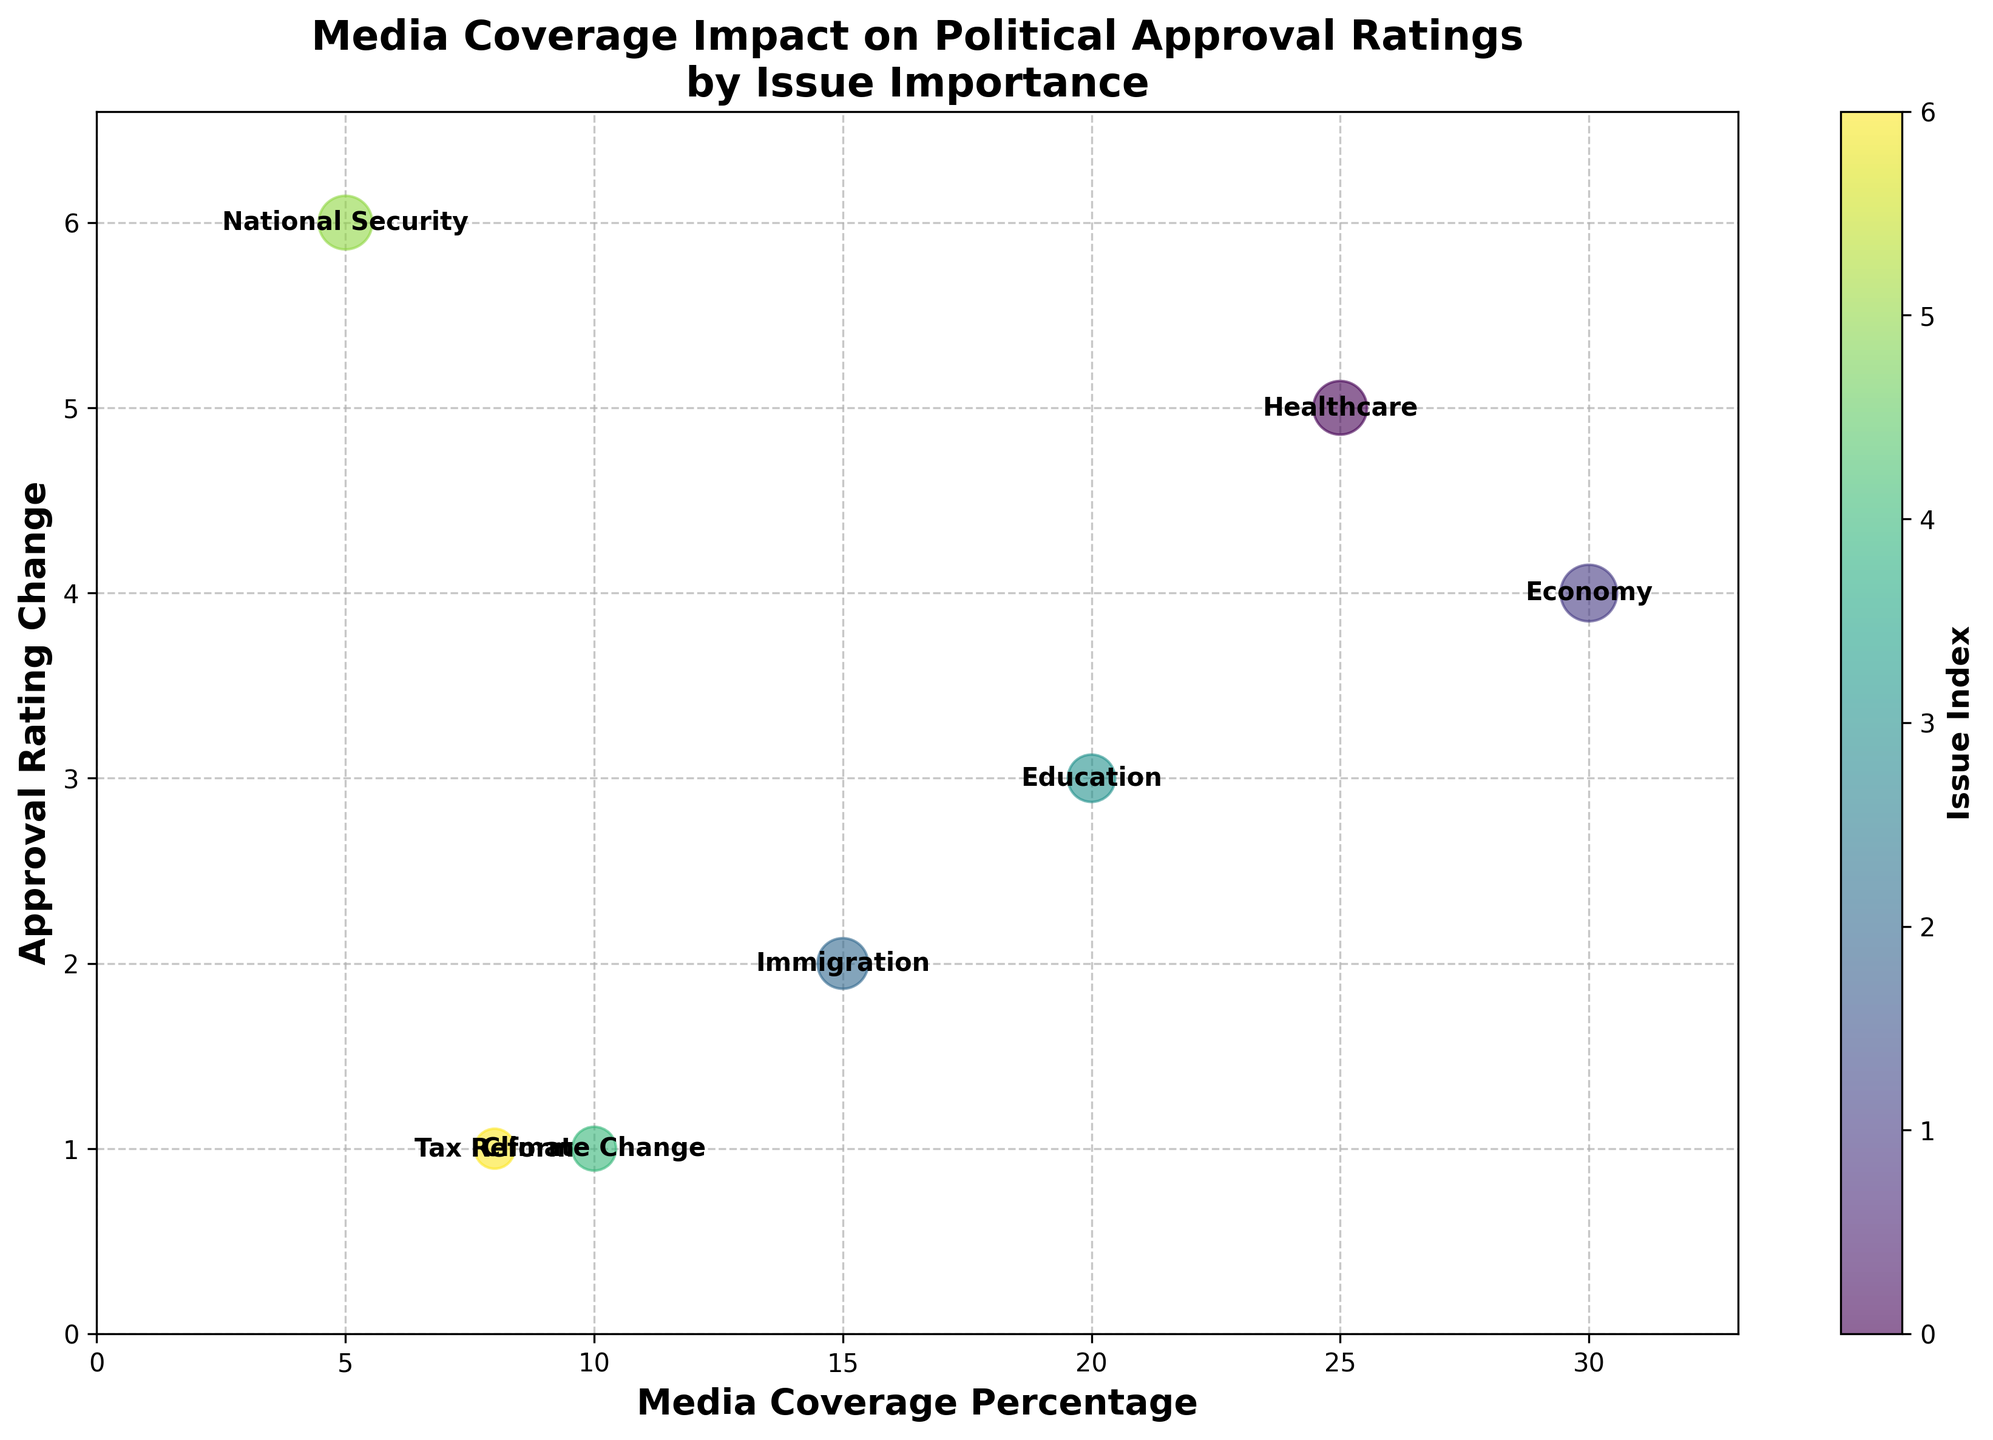What is the title of the chart? The title is usually displayed at the top of the chart. It provides a summary of what the chart is about.
Answer: Media Coverage Impact on Political Approval Ratings by Issue Importance What are the x-axis and y-axis labels? The x-axis label indicates what each point's horizontal position represents. The y-axis label indicates what each point's vertical position represents.
Answer: x-axis: Media Coverage Percentage, y-axis: Approval Rating Change How many issues are represented in the chart? Count each uniquely labeled bubble, as each corresponds to an issue. Annotated labels help identify them.
Answer: 7 Which issue has the highest approval rating change? Look for the bubble positioned highest on the y-axis since this implies the greatest approval rating change.
Answer: National Security What is the range of Media Coverage Percentage? Check the extreme left and right positions along the x-axis to determine the smallest and largest values.
Answer: 0 to 30 What's the total Media Coverage Percentage for the issues that have an Approval Rating Change greater than or equal to 3? Identify the issues with Approval Rating Change ≥ 3, then sum their Media Coverage Percentages. Economy (30) + Healthcare (25) + Education (20) = 75
Answer: 75 Which issue has the smallest Media Coverage Percentage and what is its Approval Rating Change? Find the bubble closest to the y-axis along the x-axis to identify the lowest percentage, then check its y-coordinate.
Answer: National Security, 6 Compare the Approval Rating Change between Healthcare and Economy. Which one has a higher change? Locate the Healthcare and Economy bubbles and compare their y-coordinates to determine which is higher.
Answer: Healthcare What is the largest Issue Importance represented in the chart? The size of the bubbles corresponds to Issue Importance. Identify the largest bubble to determine the highest importance.
Answer: Economy (10) How does Issue Importance correlate with Approval Rating Change? Does a higher importance generally imply a higher change? Observe the trend between bubble sizes and their vertical position. Larger bubbles (higher importance) should ideally have higher y-coordinates if there's a positive correlation.
Answer: No clear correlation 